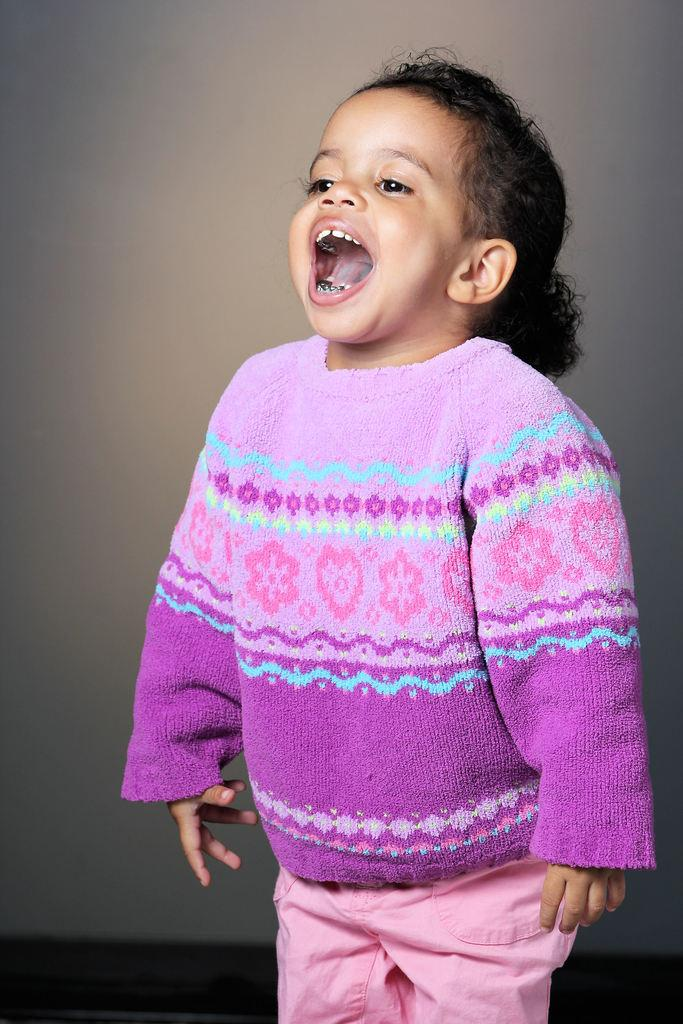What is the main subject of the image? The main subject of the image is a kid. Where is the kid positioned in the image? The kid is standing in the center of the image. What expression does the kid have? The kid is smiling. What type of apparel is the kid wearing in the image? The provided facts do not mention any specific apparel the kid is wearing. Is there any gold visible in the image? There is no mention of gold in the provided facts. What type of noise can be heard in the image? The provided facts do not mention any sounds or noises in the image. 